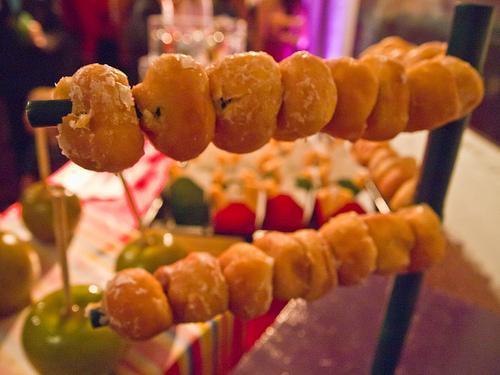How many donut holes on on the top rack?
Give a very brief answer. 8. 